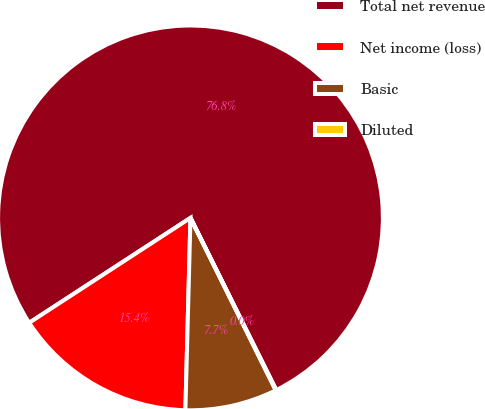Convert chart to OTSL. <chart><loc_0><loc_0><loc_500><loc_500><pie_chart><fcel>Total net revenue<fcel>Net income (loss)<fcel>Basic<fcel>Diluted<nl><fcel>76.82%<fcel>15.4%<fcel>7.73%<fcel>0.05%<nl></chart> 